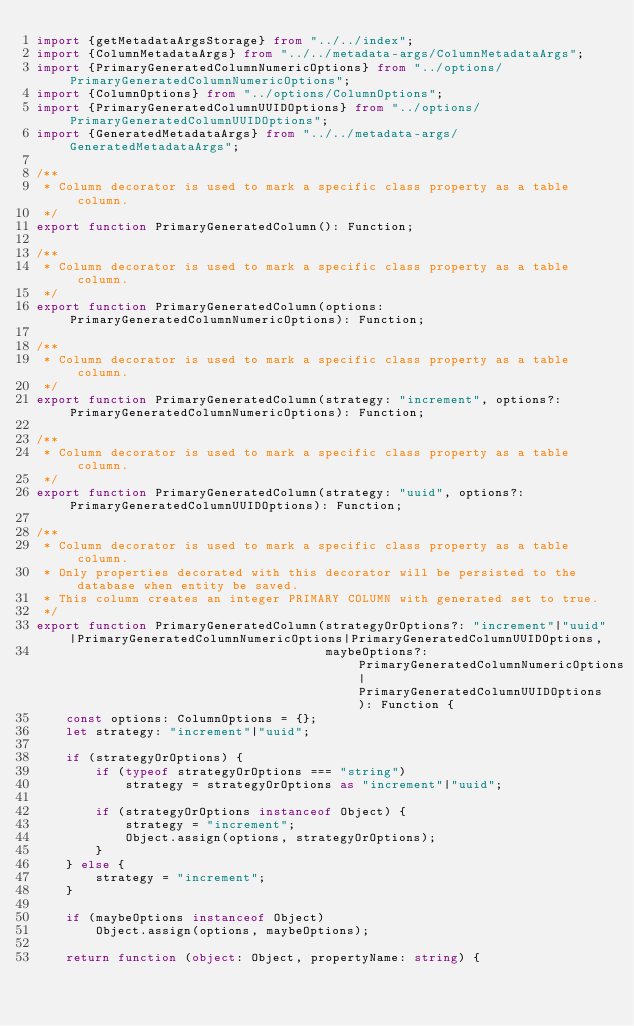<code> <loc_0><loc_0><loc_500><loc_500><_TypeScript_>import {getMetadataArgsStorage} from "../../index";
import {ColumnMetadataArgs} from "../../metadata-args/ColumnMetadataArgs";
import {PrimaryGeneratedColumnNumericOptions} from "../options/PrimaryGeneratedColumnNumericOptions";
import {ColumnOptions} from "../options/ColumnOptions";
import {PrimaryGeneratedColumnUUIDOptions} from "../options/PrimaryGeneratedColumnUUIDOptions";
import {GeneratedMetadataArgs} from "../../metadata-args/GeneratedMetadataArgs";

/**
 * Column decorator is used to mark a specific class property as a table column.
 */
export function PrimaryGeneratedColumn(): Function;

/**
 * Column decorator is used to mark a specific class property as a table column.
 */
export function PrimaryGeneratedColumn(options: PrimaryGeneratedColumnNumericOptions): Function;

/**
 * Column decorator is used to mark a specific class property as a table column.
 */
export function PrimaryGeneratedColumn(strategy: "increment", options?: PrimaryGeneratedColumnNumericOptions): Function;

/**
 * Column decorator is used to mark a specific class property as a table column.
 */
export function PrimaryGeneratedColumn(strategy: "uuid", options?: PrimaryGeneratedColumnUUIDOptions): Function;

/**
 * Column decorator is used to mark a specific class property as a table column.
 * Only properties decorated with this decorator will be persisted to the database when entity be saved.
 * This column creates an integer PRIMARY COLUMN with generated set to true.
 */
export function PrimaryGeneratedColumn(strategyOrOptions?: "increment"|"uuid"|PrimaryGeneratedColumnNumericOptions|PrimaryGeneratedColumnUUIDOptions,
                                       maybeOptions?: PrimaryGeneratedColumnNumericOptions|PrimaryGeneratedColumnUUIDOptions): Function {
    const options: ColumnOptions = {};
    let strategy: "increment"|"uuid";

    if (strategyOrOptions) {
        if (typeof strategyOrOptions === "string")
            strategy = strategyOrOptions as "increment"|"uuid";

        if (strategyOrOptions instanceof Object) {
            strategy = "increment";
            Object.assign(options, strategyOrOptions);
        }
    } else {
        strategy = "increment";
    }

    if (maybeOptions instanceof Object)
        Object.assign(options, maybeOptions);

    return function (object: Object, propertyName: string) {
</code> 